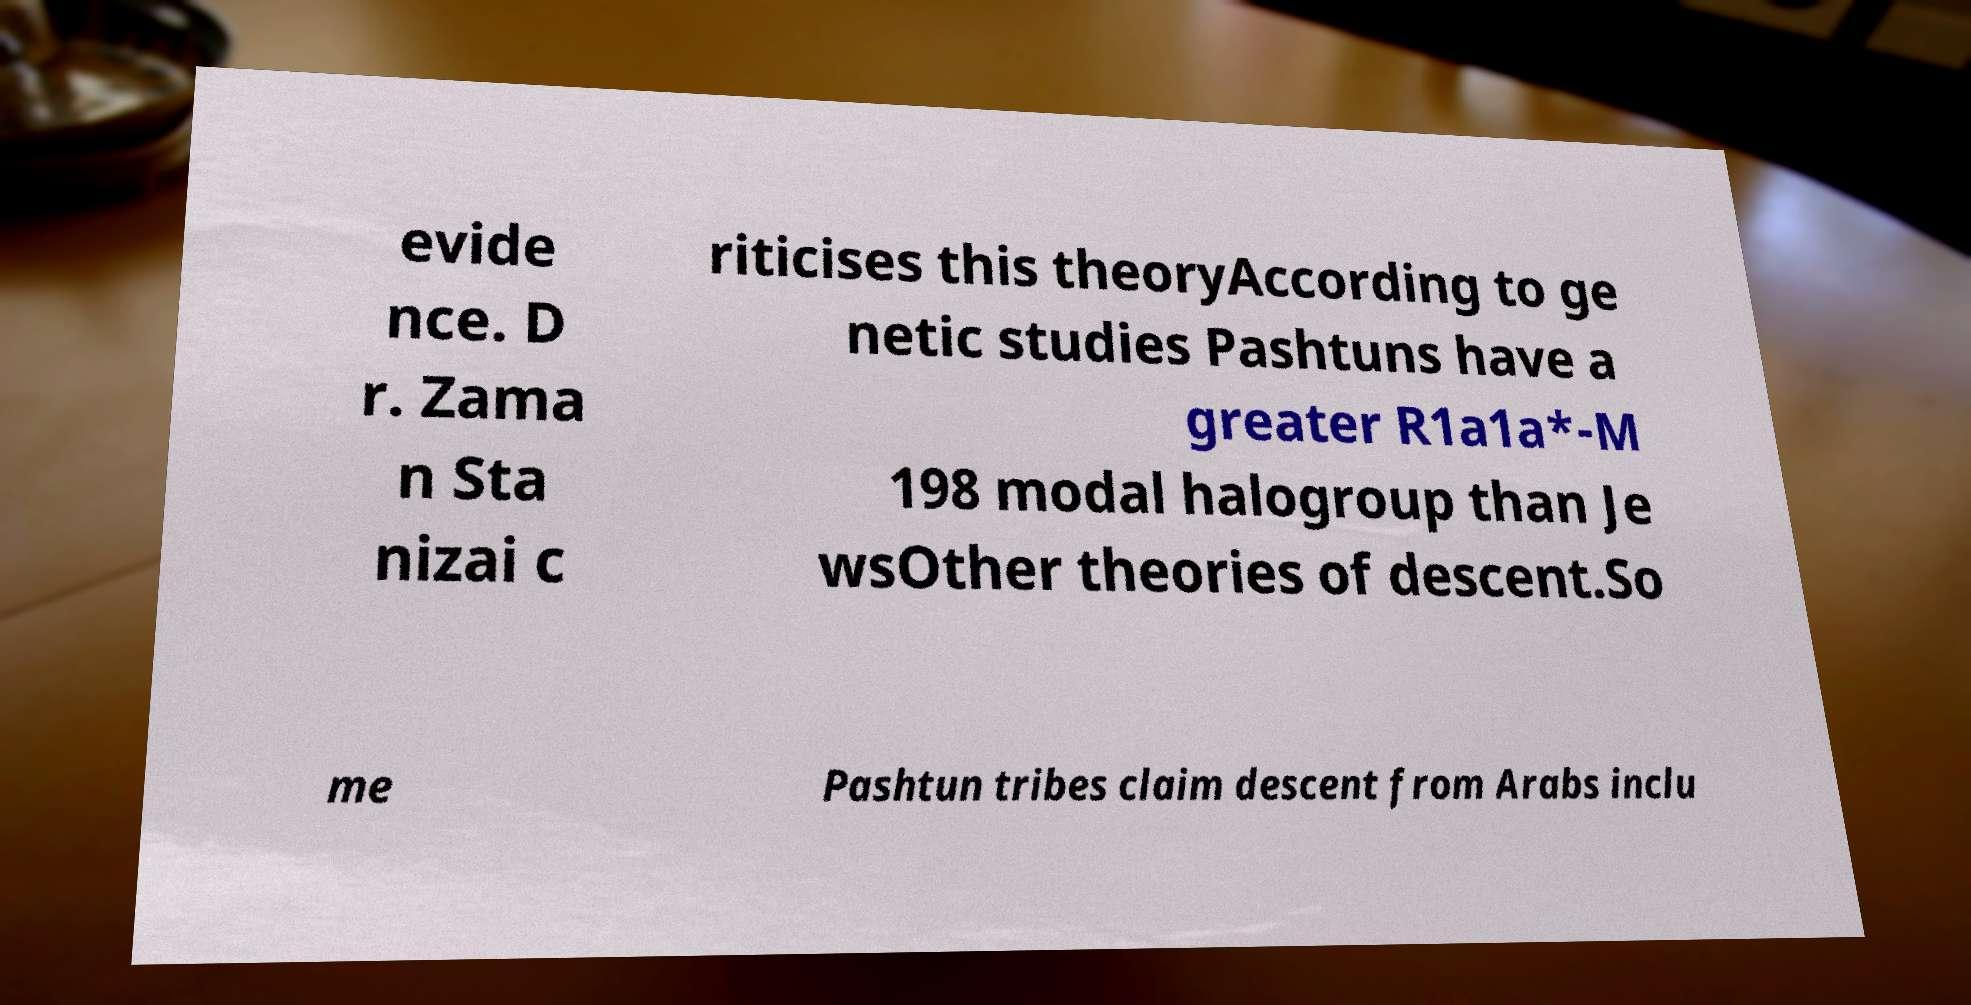Please read and relay the text visible in this image. What does it say? evide nce. D r. Zama n Sta nizai c riticises this theoryAccording to ge netic studies Pashtuns have a greater R1a1a*-M 198 modal halogroup than Je wsOther theories of descent.So me Pashtun tribes claim descent from Arabs inclu 